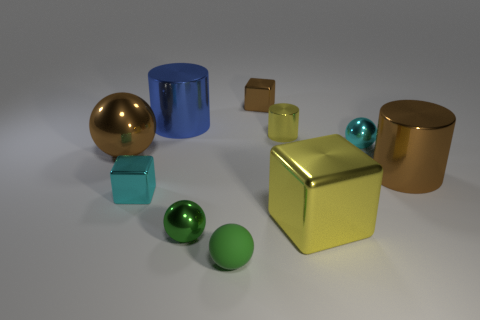How many yellow cylinders are the same size as the brown ball?
Your response must be concise. 0. The metal cylinder on the left side of the small green rubber thing is what color?
Keep it short and to the point. Blue. What number of other objects are there of the same size as the green rubber thing?
Provide a short and direct response. 5. How big is the cube that is behind the yellow block and in front of the brown cylinder?
Make the answer very short. Small. There is a large metal cube; is its color the same as the big cylinder behind the brown shiny cylinder?
Keep it short and to the point. No. Is there another big shiny thing that has the same shape as the large blue thing?
Keep it short and to the point. Yes. What number of things are small green metallic things or small blocks behind the small cylinder?
Your answer should be compact. 2. What number of other objects are there of the same material as the cyan block?
Your answer should be very brief. 8. What number of things are cyan things or cyan spheres?
Offer a very short reply. 2. Are there more small cyan things that are in front of the small cyan cube than yellow metal cylinders in front of the cyan ball?
Your answer should be very brief. No. 